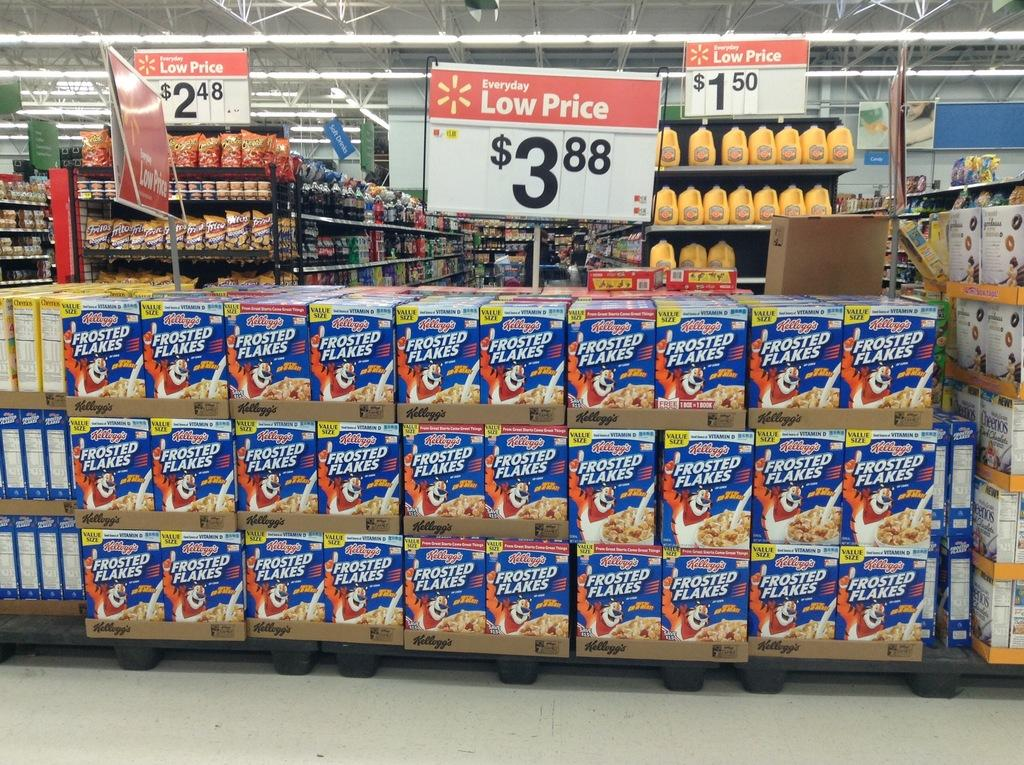Provide a one-sentence caption for the provided image. Boxes of frosted flake cereal is for sale for $3.88. 